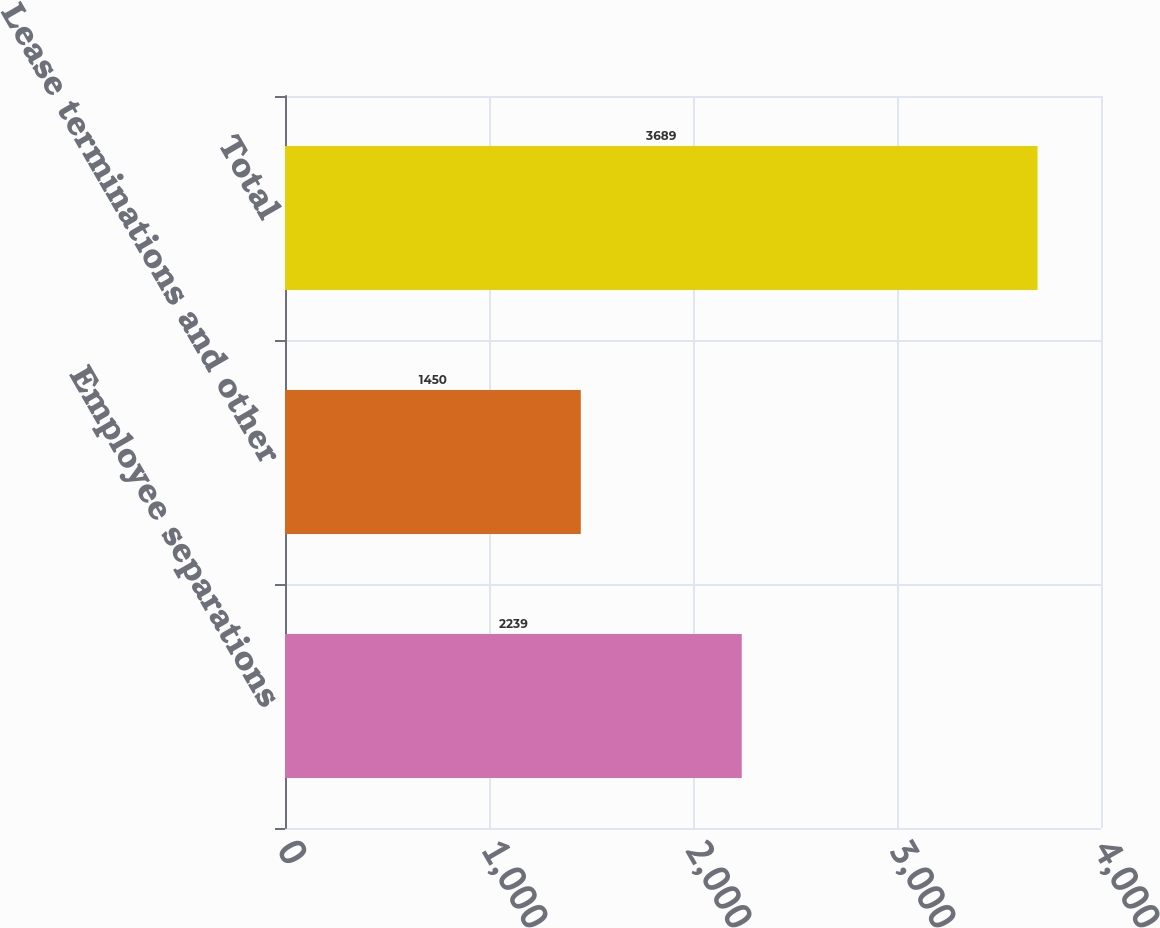<chart> <loc_0><loc_0><loc_500><loc_500><bar_chart><fcel>Employee separations<fcel>Lease terminations and other<fcel>Total<nl><fcel>2239<fcel>1450<fcel>3689<nl></chart> 